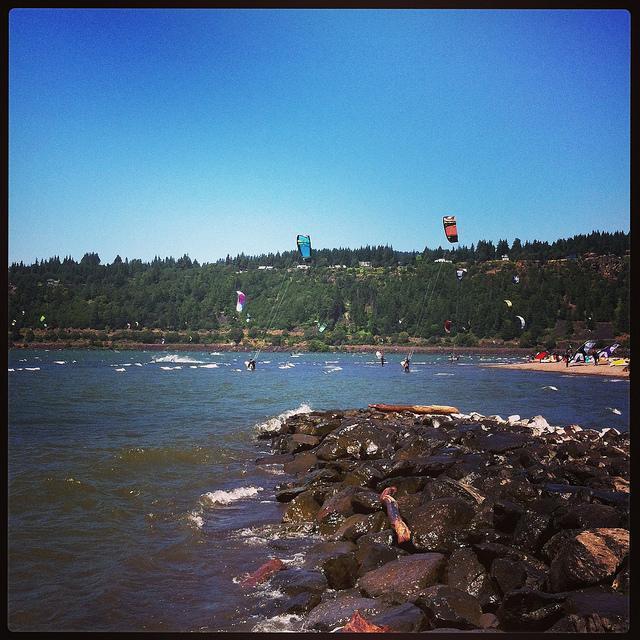How many parasailers are there?
Give a very brief answer. 3. How many boxes of pizza are there?
Give a very brief answer. 0. 